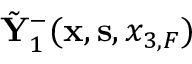Convert formula to latex. <formula><loc_0><loc_0><loc_500><loc_500>\tilde { Y } _ { 1 } ^ { - } ( { x } , { s } , { x _ { 3 , F } } )</formula> 